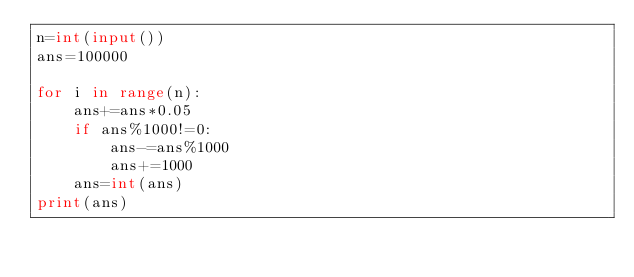<code> <loc_0><loc_0><loc_500><loc_500><_Python_>n=int(input())
ans=100000

for i in range(n):
    ans+=ans*0.05
    if ans%1000!=0:
        ans-=ans%1000
        ans+=1000
    ans=int(ans)
print(ans)
</code> 